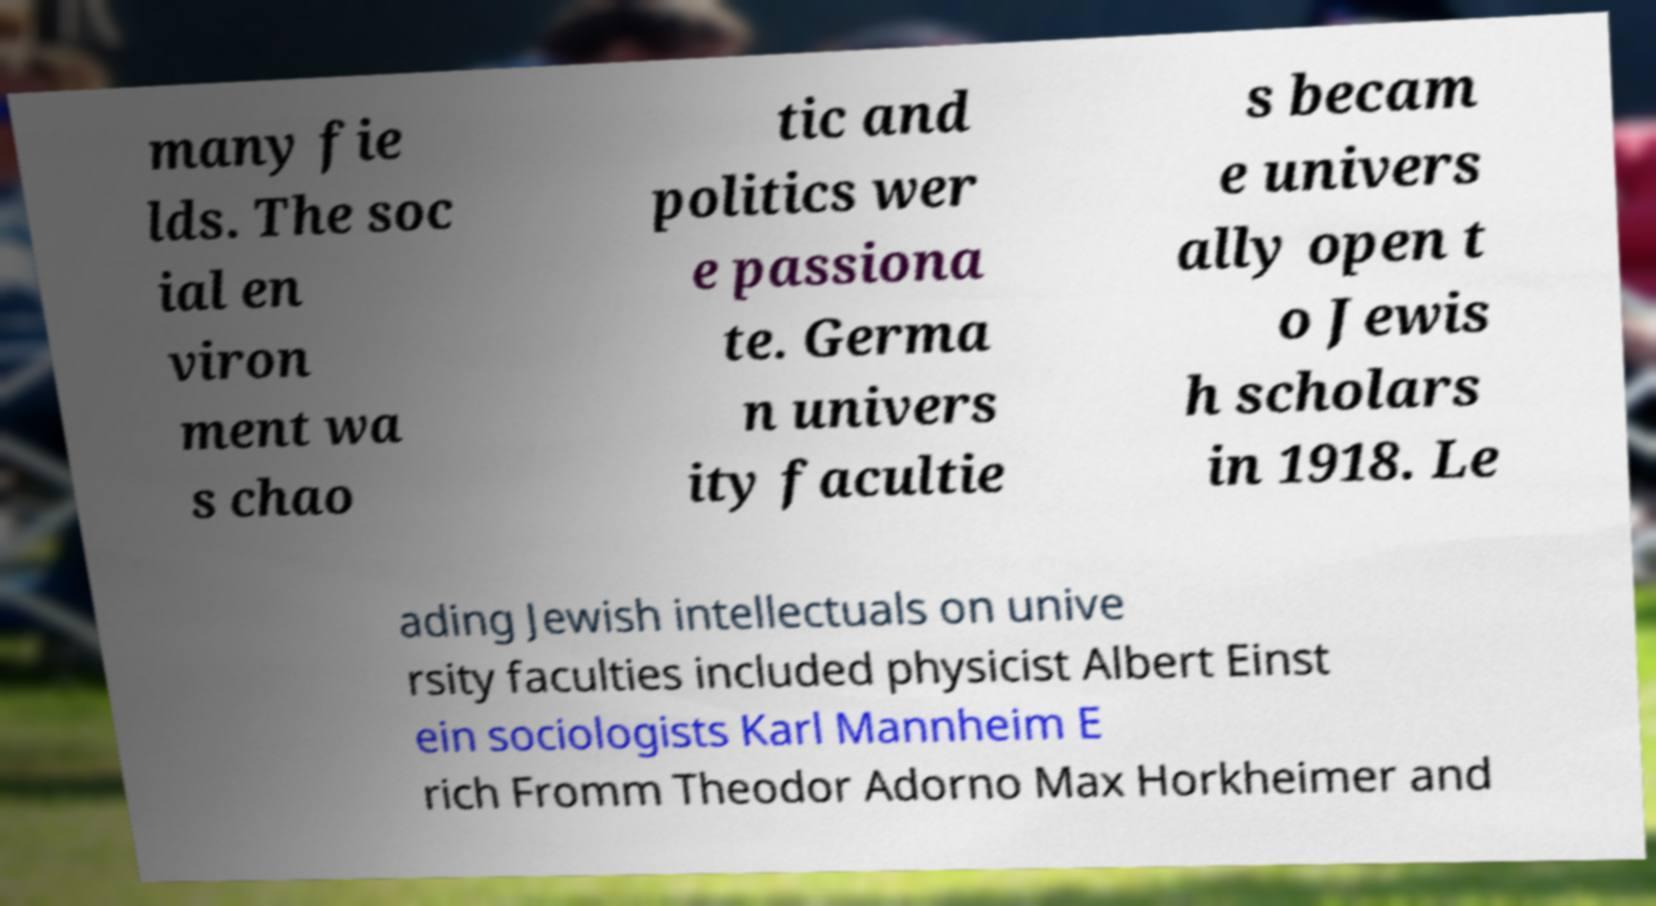What messages or text are displayed in this image? I need them in a readable, typed format. many fie lds. The soc ial en viron ment wa s chao tic and politics wer e passiona te. Germa n univers ity facultie s becam e univers ally open t o Jewis h scholars in 1918. Le ading Jewish intellectuals on unive rsity faculties included physicist Albert Einst ein sociologists Karl Mannheim E rich Fromm Theodor Adorno Max Horkheimer and 